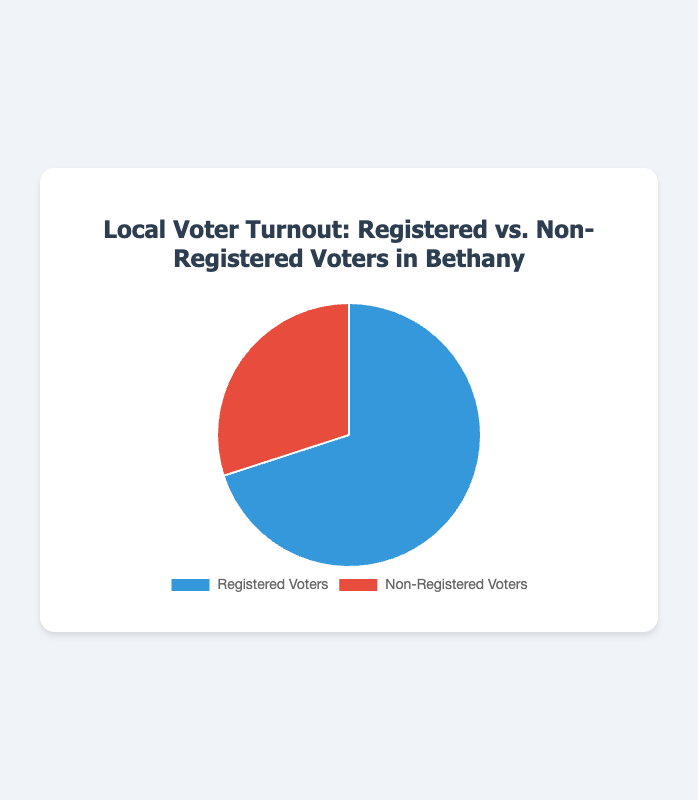what percentage of voters in Bethany are registered? To find the percentage of registered voters, divide the number of registered voters by the total number of voters (both registered and non-registered), then multiply by 100. Registered voters: 3500, Total voters: 3500 + 1500 = 5000. So, (3500 / 5000) * 100 = 70%
Answer: 70% How many more registered voters are there than non-registered voters? Subtract the number of non-registered voters from the number of registered voters. Registered voters: 3500, Non-registered voters: 1500. So, 3500 - 1500 = 2000
Answer: 2000 What is the total number of voters in Bethany? Add the number of registered voters and non-registered voters. Registered voters: 3500, Non-registered voters: 1500. So, 3500 + 1500 = 5000
Answer: 5000 Which category has a higher count, registered voters or non-registered voters? Compare the counts of both categories. Registered voters: 3500, Non-registered voters: 1500. 3500 is greater than 1500, so registered voters have a higher count
Answer: Registered voters What fraction of voters in Bethany are non-registered? To find the fraction of non-registered voters, divide the number of non-registered voters by the total number of voters. Non-registered voters: 1500, Total voters: 3500 + 1500 = 5000. So, 1500 / 5000 = 3/10
Answer: 3/10 By what percentage is the number of registered voters higher than non-registered voters? To find the percentage difference, subtract the number of non-registered voters from the number of registered voters, divide by the number of non-registered voters, and multiply by 100. (3500 - 1500) / 1500 * 100 = 133.33%
Answer: 133.33% What is the count of non-registered voters represented in percentages? To find the percentage, divide the number of non-registered voters by the total number of voters and multiply by 100. Non-registered voters: 1500, Total voters: 3500 + 1500 = 5000. So, (1500 / 5000) * 100 = 30%
Answer: 30% What are the colors used to represent each category in the pie chart? The color blue represents registered voters, and the color red represents non-registered voters. This is shown by the color key in the pie chart showing blue and red slices
Answer: Blue, Red 